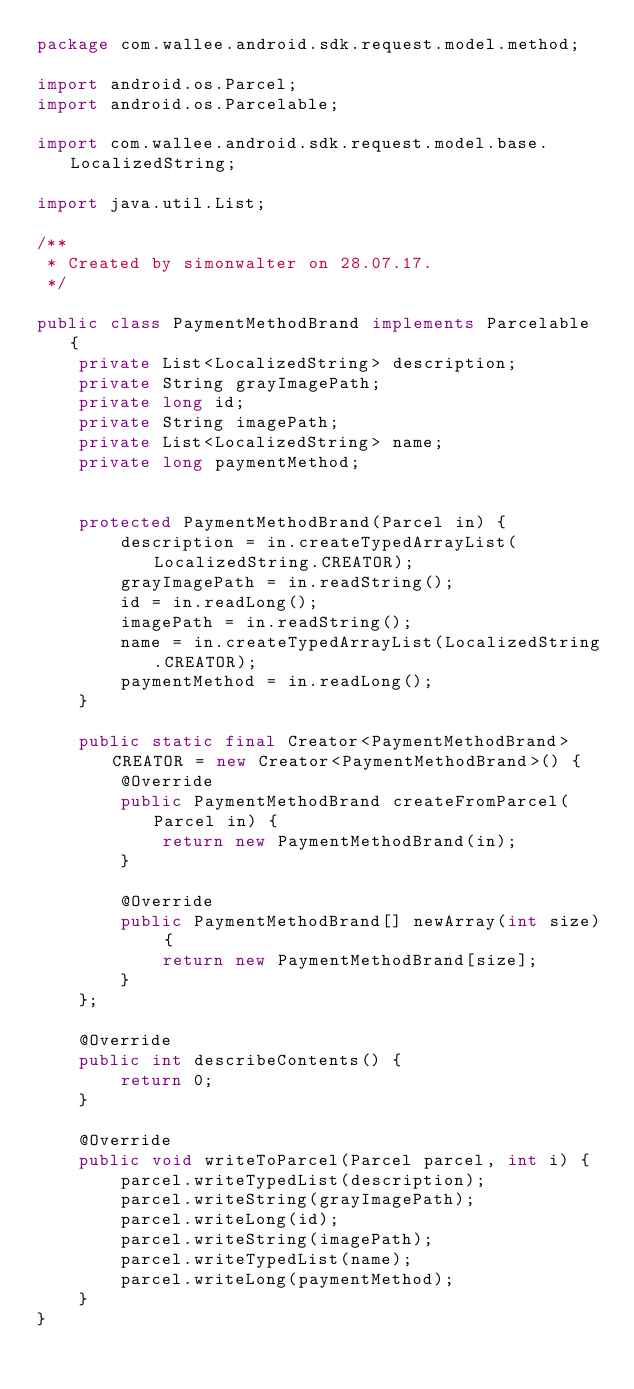<code> <loc_0><loc_0><loc_500><loc_500><_Java_>package com.wallee.android.sdk.request.model.method;

import android.os.Parcel;
import android.os.Parcelable;

import com.wallee.android.sdk.request.model.base.LocalizedString;

import java.util.List;

/**
 * Created by simonwalter on 28.07.17.
 */

public class PaymentMethodBrand implements Parcelable {
    private List<LocalizedString> description;
    private String grayImagePath;
    private long id;
    private String imagePath;
    private List<LocalizedString> name;
    private long paymentMethod;


    protected PaymentMethodBrand(Parcel in) {
        description = in.createTypedArrayList(LocalizedString.CREATOR);
        grayImagePath = in.readString();
        id = in.readLong();
        imagePath = in.readString();
        name = in.createTypedArrayList(LocalizedString.CREATOR);
        paymentMethod = in.readLong();
    }

    public static final Creator<PaymentMethodBrand> CREATOR = new Creator<PaymentMethodBrand>() {
        @Override
        public PaymentMethodBrand createFromParcel(Parcel in) {
            return new PaymentMethodBrand(in);
        }

        @Override
        public PaymentMethodBrand[] newArray(int size) {
            return new PaymentMethodBrand[size];
        }
    };

    @Override
    public int describeContents() {
        return 0;
    }

    @Override
    public void writeToParcel(Parcel parcel, int i) {
        parcel.writeTypedList(description);
        parcel.writeString(grayImagePath);
        parcel.writeLong(id);
        parcel.writeString(imagePath);
        parcel.writeTypedList(name);
        parcel.writeLong(paymentMethod);
    }
}
</code> 